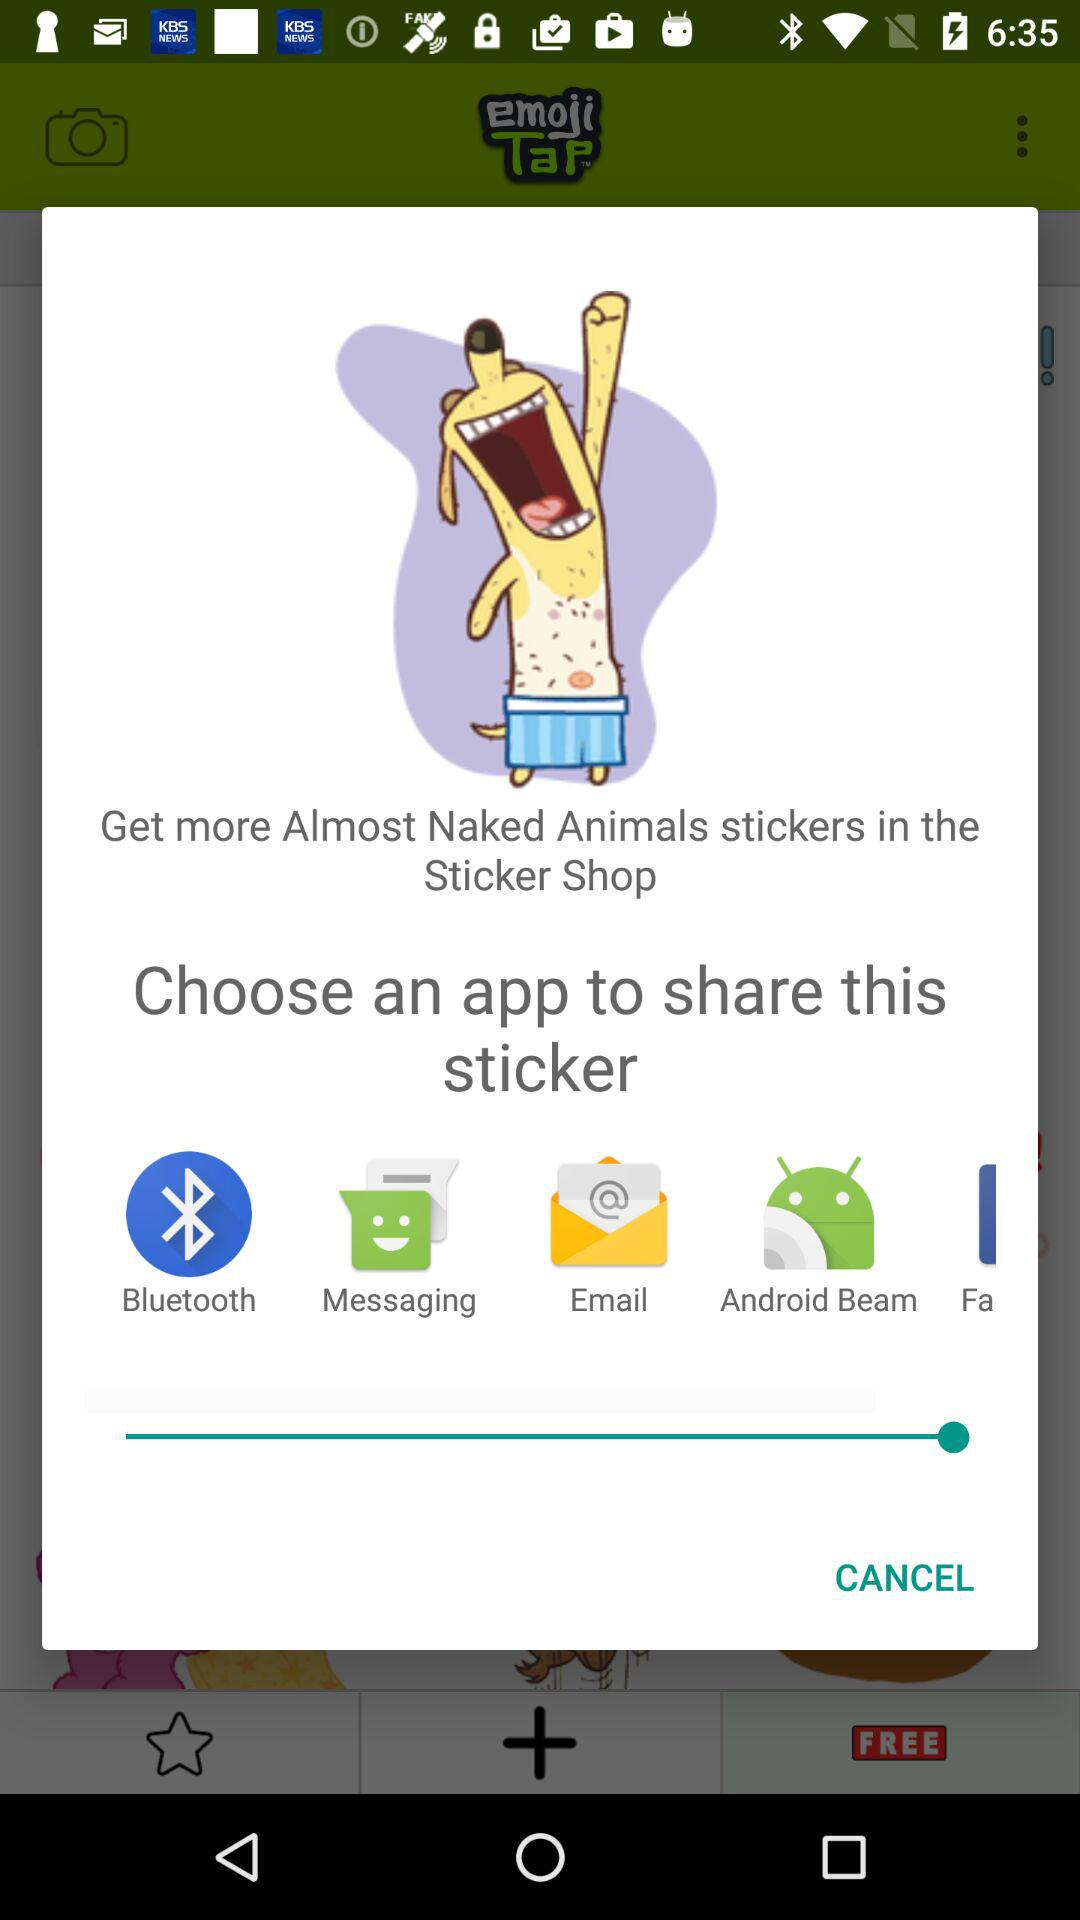How many app options are there to share the sticker?
Answer the question using a single word or phrase. 5 